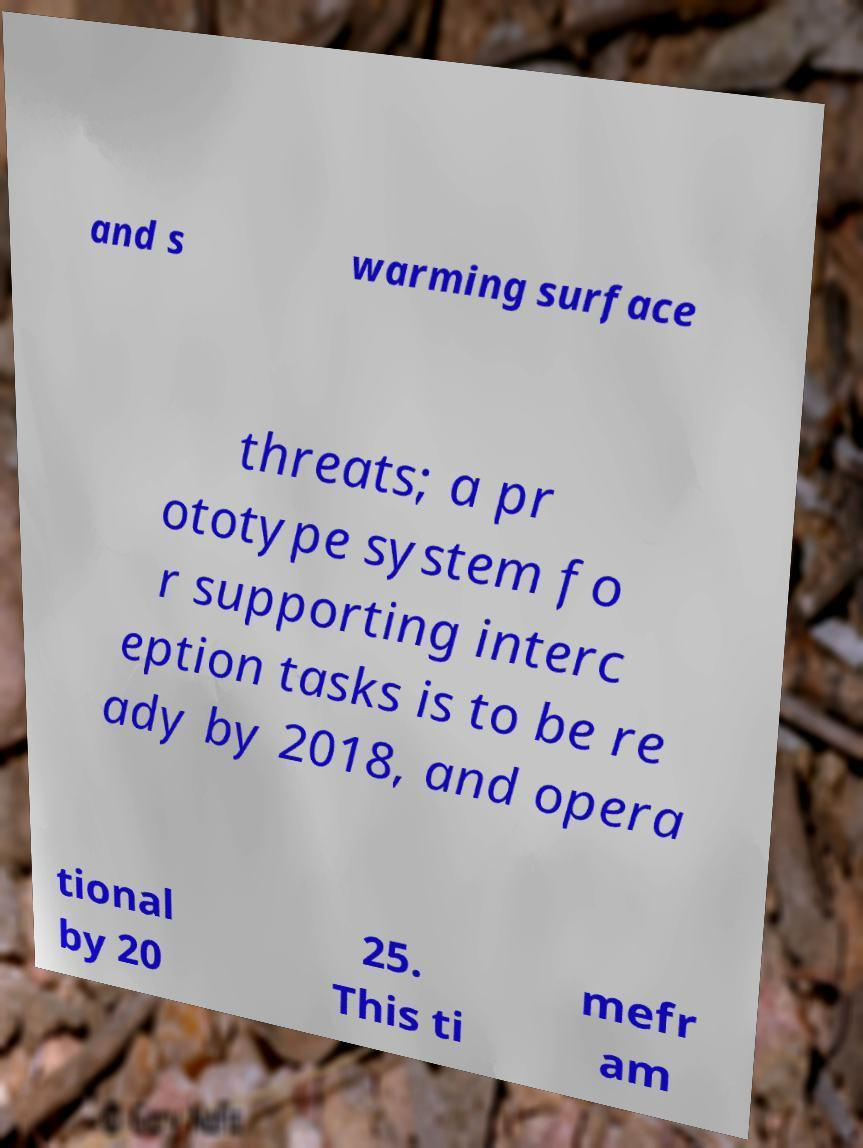Could you assist in decoding the text presented in this image and type it out clearly? and s warming surface threats; a pr ototype system fo r supporting interc eption tasks is to be re ady by 2018, and opera tional by 20 25. This ti mefr am 